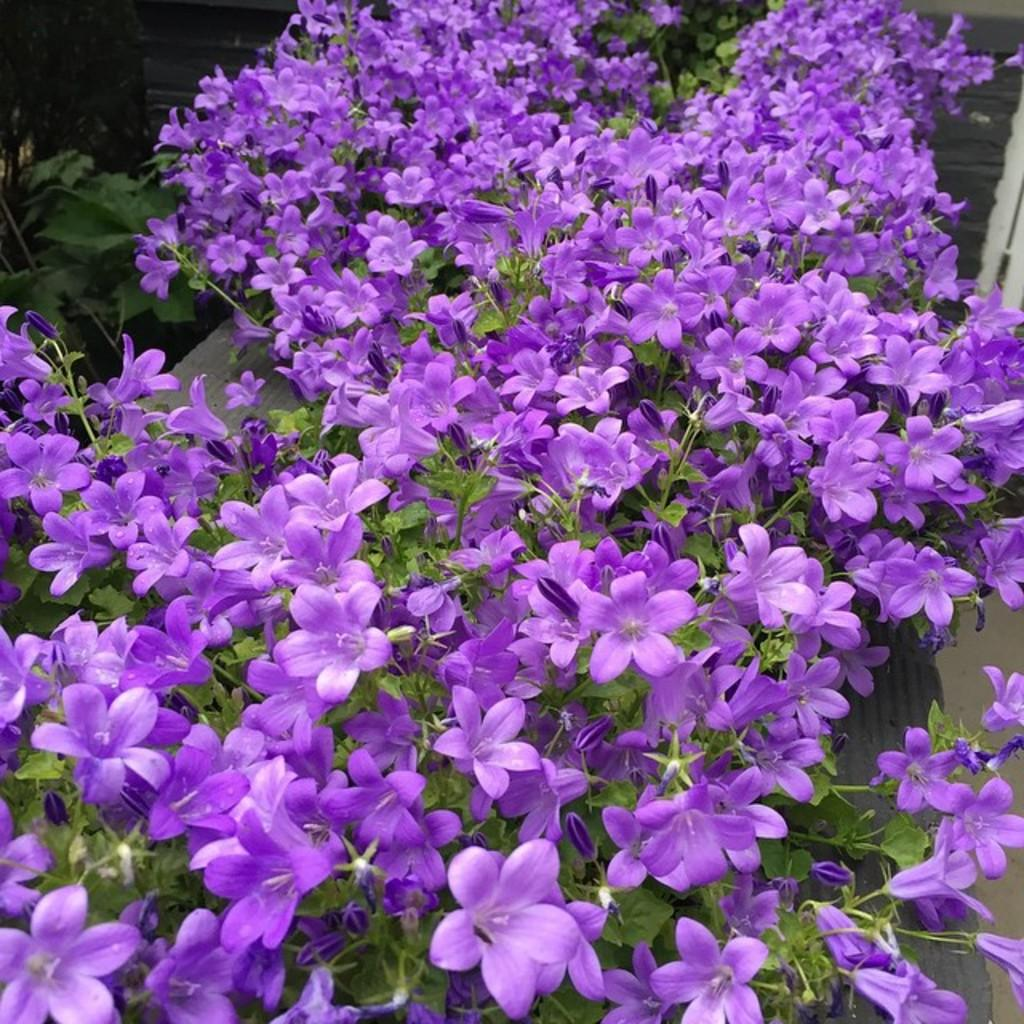What type of plants are visible in the image? There are plants with flowers in the image. What else can be seen in the image besides the plants? There are objects present in the image. What type of pie is being served in the image? There is no pie present in the image; it features plants with flowers and objects. How does the pump contribute to the image? There is no pump present in the image. 